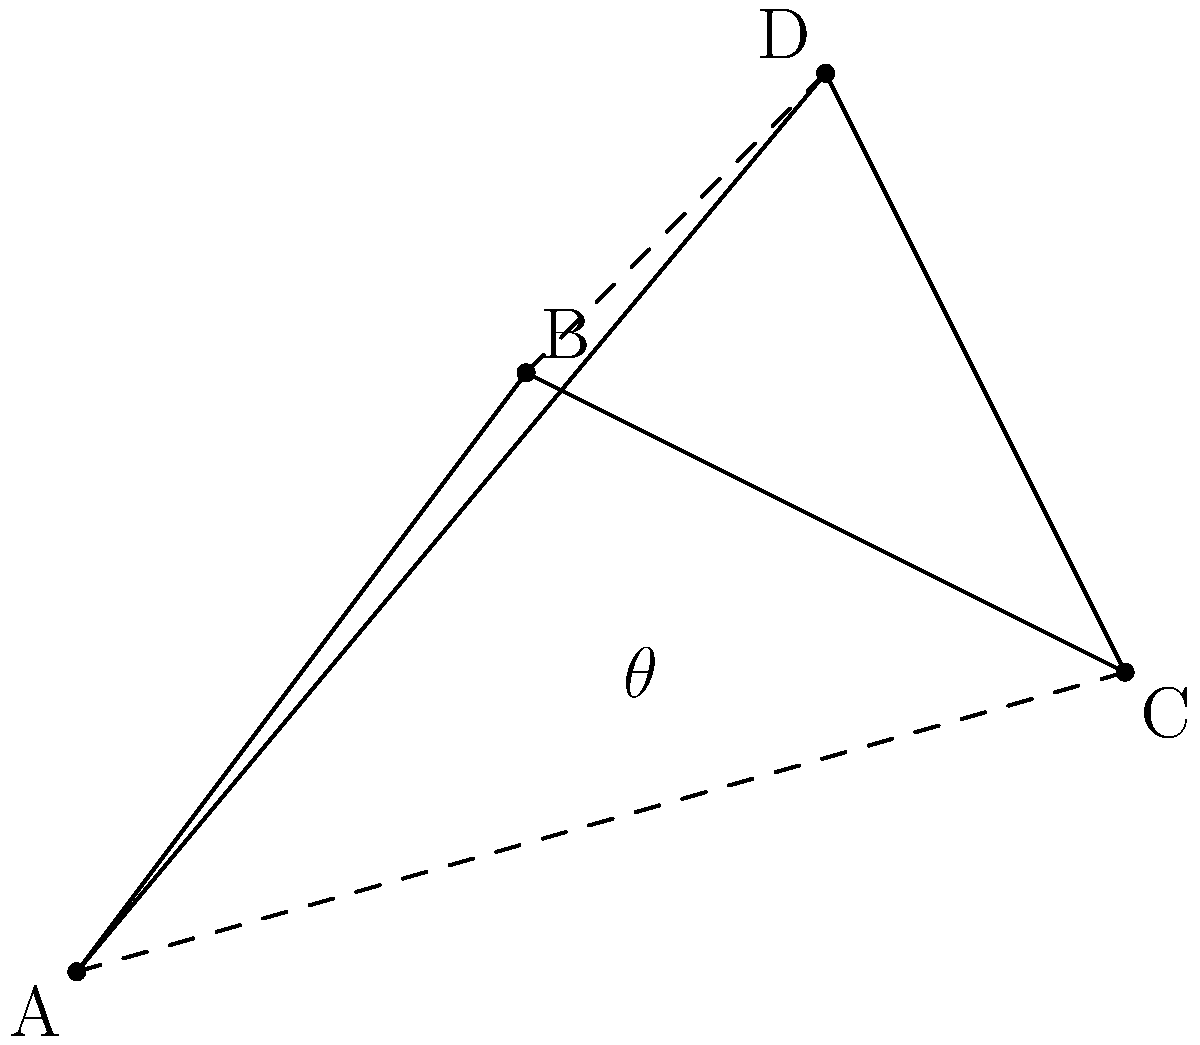In the tactical formation diagram above, four players (A, B, C, and D) are positioned on the field. If the distance between players A and C is 8 meters, estimate the angle $\theta$ formed at the intersection of AC and BD to the nearest degree. To solve this problem, we'll follow these steps:

1) First, we need to recognize that the diagram forms a quadrilateral ABCD with diagonals AC and BD intersecting at angle $\theta$.

2) We're given that the distance AC is 8 meters. In the coordinate system of the diagram, AC forms the hypotenuse of a right triangle with sides 7 units (horizontal) and 2 units (vertical).

3) We can use the Pythagorean theorem to find the scale of the diagram:

   $7^2 + 2^2 = x^2$
   $49 + 4 = x^2$
   $53 = x^2$
   $x = \sqrt{53} \approx 7.28$

4) So, 7.28 units in the diagram represent 8 meters in reality. The scale is approximately 1.1 meters per unit.

5) Now, we can find the coordinates of the intersection point of AC and BD. It's approximately at (3.5, 2).

6) To find angle $\theta$, we need to calculate two vectors:
   $\vec{v1} = C - A = (7,2) - (0,0) = (7,2)$
   $\vec{v2} = D - B = (5,6) - (3,4) = (2,2)$

7) The angle between these vectors can be calculated using the dot product formula:

   $\cos(\theta) = \frac{\vec{v1} \cdot \vec{v2}}{|\vec{v1}||\vec{v2}|}$

8) Calculating:
   $\vec{v1} \cdot \vec{v2} = 7(2) + 2(2) = 18$
   $|\vec{v1}| = \sqrt{7^2 + 2^2} = \sqrt{53}$
   $|\vec{v2}| = \sqrt{2^2 + 2^2} = 2\sqrt{2}$

9) Substituting:
   $\cos(\theta) = \frac{18}{\sqrt{53} \cdot 2\sqrt{2}} = \frac{9}{\sqrt{106}} \approx 0.8746$

10) Taking the inverse cosine and converting to degrees:
    $\theta = \arccos(0.8746) \approx 28.9°$

11) Rounding to the nearest degree, we get 29°.
Answer: 29° 